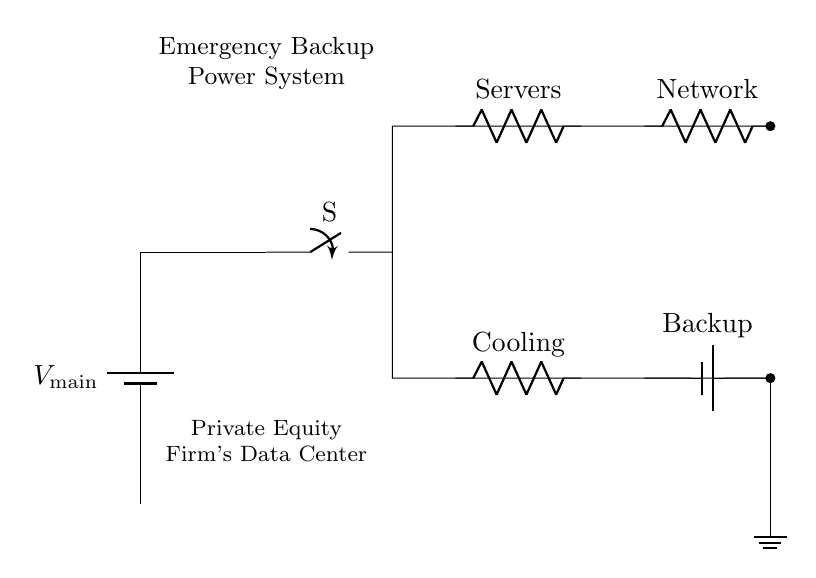What type of circuit is depicted in the diagram? The circuit is a parallel circuit, where multiple branches allow components to receive the same voltage from the source independently.
Answer: Parallel What component provides the main power supply? The main power supply component in the circuit is represented as a battery, which indicates that it supplies power.
Answer: Battery How many parallel branches are depicted in the circuit? There are four parallel branches shown in the circuit, which are dedicated to servers, network equipment, cooling system, and backup generators.
Answer: Four What is the function of the switch in this circuit? The switch is used to control the connection of the circuit to the main power, allowing or interrupting power flow to the entire system.
Answer: Control Which component is designated for cooling purposes? The cooling system is represented by a resistor component labeled "Cooling," indicating its role in the circuit.
Answer: Cooling If one branch fails, what happens to the other branches? In a parallel circuit configuration, if one branch fails, the other branches remain operational and continue to function without interruption.
Answer: Operational What provides backup power in this emergency system? The backup power is provided by a battery designated as "Backup," which serves to supply energy in case the main power fails.
Answer: Backup 